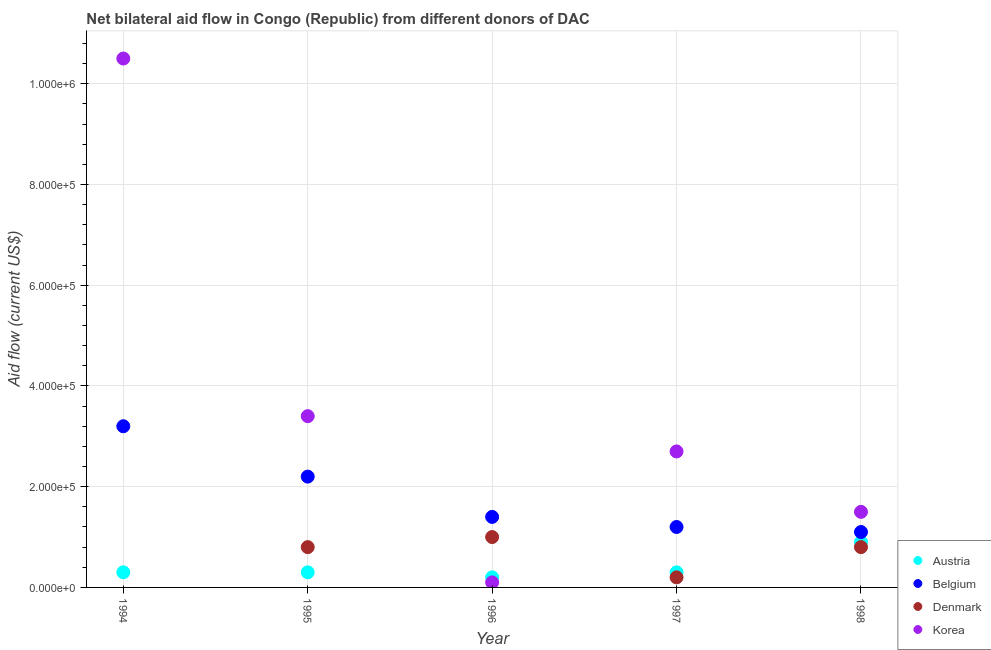How many different coloured dotlines are there?
Give a very brief answer. 4. What is the amount of aid given by korea in 1995?
Offer a terse response. 3.40e+05. Across all years, what is the maximum amount of aid given by austria?
Ensure brevity in your answer.  9.00e+04. Across all years, what is the minimum amount of aid given by denmark?
Make the answer very short. 0. What is the total amount of aid given by austria in the graph?
Provide a succinct answer. 2.00e+05. What is the difference between the amount of aid given by korea in 1994 and that in 1996?
Provide a succinct answer. 1.04e+06. What is the difference between the amount of aid given by denmark in 1997 and the amount of aid given by belgium in 1998?
Your answer should be compact. -9.00e+04. What is the average amount of aid given by denmark per year?
Offer a terse response. 5.60e+04. In the year 1998, what is the difference between the amount of aid given by austria and amount of aid given by denmark?
Offer a very short reply. 10000. In how many years, is the amount of aid given by denmark greater than 480000 US$?
Provide a short and direct response. 0. What is the ratio of the amount of aid given by korea in 1994 to that in 1997?
Your answer should be very brief. 3.89. What is the difference between the highest and the second highest amount of aid given by korea?
Offer a terse response. 7.10e+05. What is the difference between the highest and the lowest amount of aid given by belgium?
Provide a short and direct response. 2.10e+05. Is the sum of the amount of aid given by austria in 1997 and 1998 greater than the maximum amount of aid given by denmark across all years?
Your response must be concise. Yes. Is it the case that in every year, the sum of the amount of aid given by denmark and amount of aid given by austria is greater than the sum of amount of aid given by belgium and amount of aid given by korea?
Your response must be concise. No. Does the amount of aid given by korea monotonically increase over the years?
Provide a short and direct response. No. Is the amount of aid given by belgium strictly greater than the amount of aid given by austria over the years?
Make the answer very short. Yes. How many years are there in the graph?
Ensure brevity in your answer.  5. Does the graph contain grids?
Offer a very short reply. Yes. What is the title of the graph?
Provide a succinct answer. Net bilateral aid flow in Congo (Republic) from different donors of DAC. Does "Korea" appear as one of the legend labels in the graph?
Provide a succinct answer. Yes. What is the label or title of the X-axis?
Offer a very short reply. Year. What is the label or title of the Y-axis?
Make the answer very short. Aid flow (current US$). What is the Aid flow (current US$) in Austria in 1994?
Your response must be concise. 3.00e+04. What is the Aid flow (current US$) in Belgium in 1994?
Your answer should be very brief. 3.20e+05. What is the Aid flow (current US$) in Korea in 1994?
Your answer should be compact. 1.05e+06. What is the Aid flow (current US$) in Austria in 1995?
Give a very brief answer. 3.00e+04. What is the Aid flow (current US$) in Korea in 1995?
Offer a terse response. 3.40e+05. What is the Aid flow (current US$) in Austria in 1996?
Ensure brevity in your answer.  2.00e+04. What is the Aid flow (current US$) in Belgium in 1996?
Your response must be concise. 1.40e+05. What is the Aid flow (current US$) of Belgium in 1997?
Your answer should be very brief. 1.20e+05. What is the Aid flow (current US$) in Korea in 1997?
Provide a short and direct response. 2.70e+05. What is the Aid flow (current US$) in Denmark in 1998?
Offer a terse response. 8.00e+04. Across all years, what is the maximum Aid flow (current US$) in Belgium?
Keep it short and to the point. 3.20e+05. Across all years, what is the maximum Aid flow (current US$) in Korea?
Your answer should be very brief. 1.05e+06. Across all years, what is the minimum Aid flow (current US$) of Austria?
Provide a succinct answer. 2.00e+04. Across all years, what is the minimum Aid flow (current US$) of Belgium?
Offer a terse response. 1.10e+05. Across all years, what is the minimum Aid flow (current US$) in Korea?
Make the answer very short. 10000. What is the total Aid flow (current US$) in Belgium in the graph?
Your answer should be compact. 9.10e+05. What is the total Aid flow (current US$) of Korea in the graph?
Your response must be concise. 1.82e+06. What is the difference between the Aid flow (current US$) in Belgium in 1994 and that in 1995?
Your answer should be compact. 1.00e+05. What is the difference between the Aid flow (current US$) of Korea in 1994 and that in 1995?
Give a very brief answer. 7.10e+05. What is the difference between the Aid flow (current US$) in Belgium in 1994 and that in 1996?
Give a very brief answer. 1.80e+05. What is the difference between the Aid flow (current US$) of Korea in 1994 and that in 1996?
Your answer should be compact. 1.04e+06. What is the difference between the Aid flow (current US$) in Austria in 1994 and that in 1997?
Keep it short and to the point. 0. What is the difference between the Aid flow (current US$) of Belgium in 1994 and that in 1997?
Your answer should be compact. 2.00e+05. What is the difference between the Aid flow (current US$) of Korea in 1994 and that in 1997?
Keep it short and to the point. 7.80e+05. What is the difference between the Aid flow (current US$) in Belgium in 1994 and that in 1998?
Your answer should be compact. 2.10e+05. What is the difference between the Aid flow (current US$) in Austria in 1995 and that in 1996?
Provide a short and direct response. 10000. What is the difference between the Aid flow (current US$) of Korea in 1995 and that in 1996?
Give a very brief answer. 3.30e+05. What is the difference between the Aid flow (current US$) in Austria in 1995 and that in 1997?
Your answer should be very brief. 0. What is the difference between the Aid flow (current US$) in Denmark in 1995 and that in 1997?
Your answer should be very brief. 6.00e+04. What is the difference between the Aid flow (current US$) of Denmark in 1995 and that in 1998?
Ensure brevity in your answer.  0. What is the difference between the Aid flow (current US$) of Korea in 1995 and that in 1998?
Provide a succinct answer. 1.90e+05. What is the difference between the Aid flow (current US$) in Austria in 1996 and that in 1997?
Ensure brevity in your answer.  -10000. What is the difference between the Aid flow (current US$) of Denmark in 1996 and that in 1997?
Your answer should be very brief. 8.00e+04. What is the difference between the Aid flow (current US$) in Korea in 1996 and that in 1997?
Your response must be concise. -2.60e+05. What is the difference between the Aid flow (current US$) in Austria in 1997 and that in 1998?
Offer a terse response. -6.00e+04. What is the difference between the Aid flow (current US$) of Denmark in 1997 and that in 1998?
Your answer should be very brief. -6.00e+04. What is the difference between the Aid flow (current US$) in Austria in 1994 and the Aid flow (current US$) in Denmark in 1995?
Keep it short and to the point. -5.00e+04. What is the difference between the Aid flow (current US$) of Austria in 1994 and the Aid flow (current US$) of Korea in 1995?
Ensure brevity in your answer.  -3.10e+05. What is the difference between the Aid flow (current US$) of Belgium in 1994 and the Aid flow (current US$) of Denmark in 1995?
Ensure brevity in your answer.  2.40e+05. What is the difference between the Aid flow (current US$) in Belgium in 1994 and the Aid flow (current US$) in Korea in 1995?
Keep it short and to the point. -2.00e+04. What is the difference between the Aid flow (current US$) in Austria in 1994 and the Aid flow (current US$) in Belgium in 1996?
Your response must be concise. -1.10e+05. What is the difference between the Aid flow (current US$) in Austria in 1994 and the Aid flow (current US$) in Belgium in 1997?
Give a very brief answer. -9.00e+04. What is the difference between the Aid flow (current US$) in Austria in 1994 and the Aid flow (current US$) in Denmark in 1997?
Your answer should be compact. 10000. What is the difference between the Aid flow (current US$) in Austria in 1994 and the Aid flow (current US$) in Korea in 1997?
Make the answer very short. -2.40e+05. What is the difference between the Aid flow (current US$) in Belgium in 1994 and the Aid flow (current US$) in Denmark in 1997?
Provide a short and direct response. 3.00e+05. What is the difference between the Aid flow (current US$) in Belgium in 1994 and the Aid flow (current US$) in Korea in 1997?
Offer a terse response. 5.00e+04. What is the difference between the Aid flow (current US$) in Austria in 1994 and the Aid flow (current US$) in Denmark in 1998?
Keep it short and to the point. -5.00e+04. What is the difference between the Aid flow (current US$) in Austria in 1994 and the Aid flow (current US$) in Korea in 1998?
Your answer should be compact. -1.20e+05. What is the difference between the Aid flow (current US$) in Austria in 1995 and the Aid flow (current US$) in Belgium in 1996?
Offer a terse response. -1.10e+05. What is the difference between the Aid flow (current US$) of Austria in 1995 and the Aid flow (current US$) of Denmark in 1996?
Keep it short and to the point. -7.00e+04. What is the difference between the Aid flow (current US$) in Belgium in 1995 and the Aid flow (current US$) in Denmark in 1996?
Ensure brevity in your answer.  1.20e+05. What is the difference between the Aid flow (current US$) in Belgium in 1995 and the Aid flow (current US$) in Korea in 1996?
Your answer should be very brief. 2.10e+05. What is the difference between the Aid flow (current US$) in Denmark in 1995 and the Aid flow (current US$) in Korea in 1996?
Give a very brief answer. 7.00e+04. What is the difference between the Aid flow (current US$) of Austria in 1995 and the Aid flow (current US$) of Korea in 1997?
Give a very brief answer. -2.40e+05. What is the difference between the Aid flow (current US$) in Austria in 1995 and the Aid flow (current US$) in Denmark in 1998?
Provide a short and direct response. -5.00e+04. What is the difference between the Aid flow (current US$) in Austria in 1995 and the Aid flow (current US$) in Korea in 1998?
Your answer should be very brief. -1.20e+05. What is the difference between the Aid flow (current US$) in Austria in 1996 and the Aid flow (current US$) in Belgium in 1997?
Give a very brief answer. -1.00e+05. What is the difference between the Aid flow (current US$) in Austria in 1996 and the Aid flow (current US$) in Korea in 1997?
Your answer should be very brief. -2.50e+05. What is the difference between the Aid flow (current US$) of Austria in 1996 and the Aid flow (current US$) of Denmark in 1998?
Your answer should be compact. -6.00e+04. What is the difference between the Aid flow (current US$) in Austria in 1996 and the Aid flow (current US$) in Korea in 1998?
Make the answer very short. -1.30e+05. What is the difference between the Aid flow (current US$) of Belgium in 1996 and the Aid flow (current US$) of Denmark in 1998?
Provide a succinct answer. 6.00e+04. What is the difference between the Aid flow (current US$) of Austria in 1997 and the Aid flow (current US$) of Belgium in 1998?
Your answer should be compact. -8.00e+04. What is the average Aid flow (current US$) in Austria per year?
Your response must be concise. 4.00e+04. What is the average Aid flow (current US$) in Belgium per year?
Make the answer very short. 1.82e+05. What is the average Aid flow (current US$) in Denmark per year?
Offer a very short reply. 5.60e+04. What is the average Aid flow (current US$) in Korea per year?
Your response must be concise. 3.64e+05. In the year 1994, what is the difference between the Aid flow (current US$) in Austria and Aid flow (current US$) in Belgium?
Offer a very short reply. -2.90e+05. In the year 1994, what is the difference between the Aid flow (current US$) in Austria and Aid flow (current US$) in Korea?
Provide a succinct answer. -1.02e+06. In the year 1994, what is the difference between the Aid flow (current US$) in Belgium and Aid flow (current US$) in Korea?
Provide a short and direct response. -7.30e+05. In the year 1995, what is the difference between the Aid flow (current US$) of Austria and Aid flow (current US$) of Belgium?
Provide a succinct answer. -1.90e+05. In the year 1995, what is the difference between the Aid flow (current US$) of Austria and Aid flow (current US$) of Korea?
Ensure brevity in your answer.  -3.10e+05. In the year 1995, what is the difference between the Aid flow (current US$) of Belgium and Aid flow (current US$) of Denmark?
Keep it short and to the point. 1.40e+05. In the year 1996, what is the difference between the Aid flow (current US$) in Austria and Aid flow (current US$) in Belgium?
Make the answer very short. -1.20e+05. In the year 1996, what is the difference between the Aid flow (current US$) of Austria and Aid flow (current US$) of Korea?
Provide a succinct answer. 10000. In the year 1996, what is the difference between the Aid flow (current US$) of Belgium and Aid flow (current US$) of Korea?
Offer a terse response. 1.30e+05. In the year 1996, what is the difference between the Aid flow (current US$) of Denmark and Aid flow (current US$) of Korea?
Your answer should be compact. 9.00e+04. In the year 1997, what is the difference between the Aid flow (current US$) in Austria and Aid flow (current US$) in Korea?
Your answer should be compact. -2.40e+05. In the year 1997, what is the difference between the Aid flow (current US$) in Belgium and Aid flow (current US$) in Korea?
Offer a terse response. -1.50e+05. In the year 1998, what is the difference between the Aid flow (current US$) of Austria and Aid flow (current US$) of Denmark?
Provide a short and direct response. 10000. In the year 1998, what is the difference between the Aid flow (current US$) of Austria and Aid flow (current US$) of Korea?
Keep it short and to the point. -6.00e+04. In the year 1998, what is the difference between the Aid flow (current US$) in Belgium and Aid flow (current US$) in Denmark?
Offer a terse response. 3.00e+04. In the year 1998, what is the difference between the Aid flow (current US$) of Belgium and Aid flow (current US$) of Korea?
Provide a short and direct response. -4.00e+04. What is the ratio of the Aid flow (current US$) in Belgium in 1994 to that in 1995?
Offer a terse response. 1.45. What is the ratio of the Aid flow (current US$) of Korea in 1994 to that in 1995?
Offer a terse response. 3.09. What is the ratio of the Aid flow (current US$) of Austria in 1994 to that in 1996?
Ensure brevity in your answer.  1.5. What is the ratio of the Aid flow (current US$) of Belgium in 1994 to that in 1996?
Offer a very short reply. 2.29. What is the ratio of the Aid flow (current US$) in Korea in 1994 to that in 1996?
Provide a short and direct response. 105. What is the ratio of the Aid flow (current US$) of Austria in 1994 to that in 1997?
Provide a short and direct response. 1. What is the ratio of the Aid flow (current US$) in Belgium in 1994 to that in 1997?
Provide a succinct answer. 2.67. What is the ratio of the Aid flow (current US$) of Korea in 1994 to that in 1997?
Keep it short and to the point. 3.89. What is the ratio of the Aid flow (current US$) of Belgium in 1994 to that in 1998?
Give a very brief answer. 2.91. What is the ratio of the Aid flow (current US$) of Belgium in 1995 to that in 1996?
Ensure brevity in your answer.  1.57. What is the ratio of the Aid flow (current US$) in Denmark in 1995 to that in 1996?
Keep it short and to the point. 0.8. What is the ratio of the Aid flow (current US$) of Belgium in 1995 to that in 1997?
Keep it short and to the point. 1.83. What is the ratio of the Aid flow (current US$) of Denmark in 1995 to that in 1997?
Offer a terse response. 4. What is the ratio of the Aid flow (current US$) of Korea in 1995 to that in 1997?
Provide a succinct answer. 1.26. What is the ratio of the Aid flow (current US$) in Denmark in 1995 to that in 1998?
Offer a very short reply. 1. What is the ratio of the Aid flow (current US$) in Korea in 1995 to that in 1998?
Your response must be concise. 2.27. What is the ratio of the Aid flow (current US$) of Austria in 1996 to that in 1997?
Provide a succinct answer. 0.67. What is the ratio of the Aid flow (current US$) in Belgium in 1996 to that in 1997?
Make the answer very short. 1.17. What is the ratio of the Aid flow (current US$) of Korea in 1996 to that in 1997?
Give a very brief answer. 0.04. What is the ratio of the Aid flow (current US$) of Austria in 1996 to that in 1998?
Ensure brevity in your answer.  0.22. What is the ratio of the Aid flow (current US$) in Belgium in 1996 to that in 1998?
Make the answer very short. 1.27. What is the ratio of the Aid flow (current US$) of Korea in 1996 to that in 1998?
Your response must be concise. 0.07. What is the difference between the highest and the second highest Aid flow (current US$) in Belgium?
Provide a succinct answer. 1.00e+05. What is the difference between the highest and the second highest Aid flow (current US$) in Denmark?
Offer a terse response. 2.00e+04. What is the difference between the highest and the second highest Aid flow (current US$) in Korea?
Your response must be concise. 7.10e+05. What is the difference between the highest and the lowest Aid flow (current US$) of Austria?
Offer a terse response. 7.00e+04. What is the difference between the highest and the lowest Aid flow (current US$) of Korea?
Your response must be concise. 1.04e+06. 